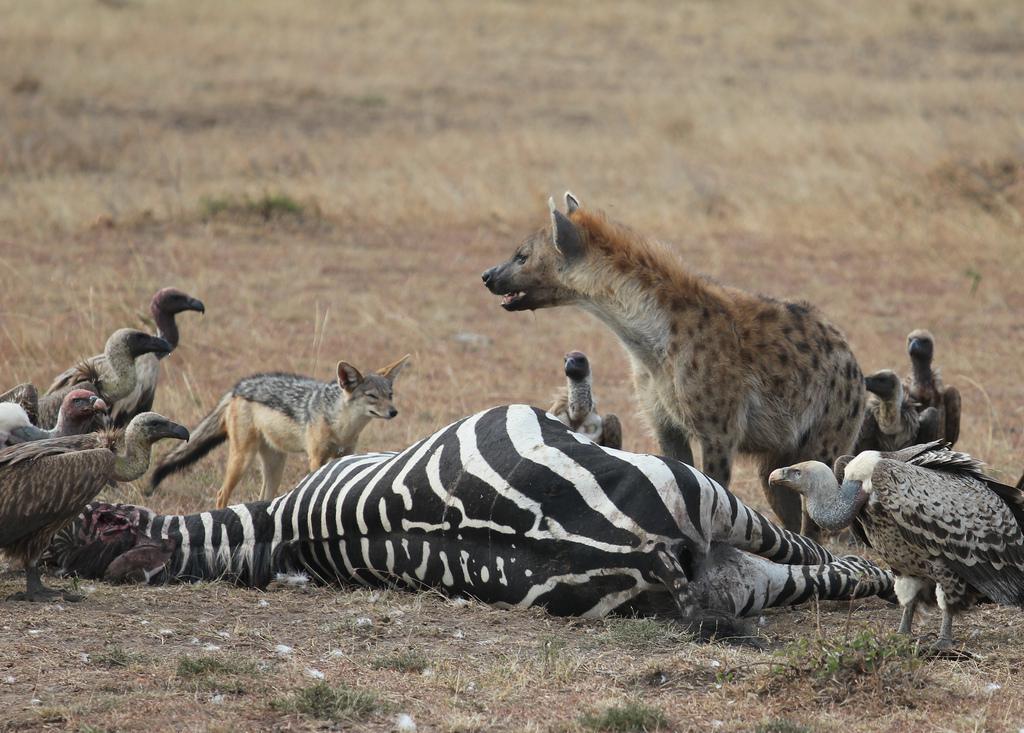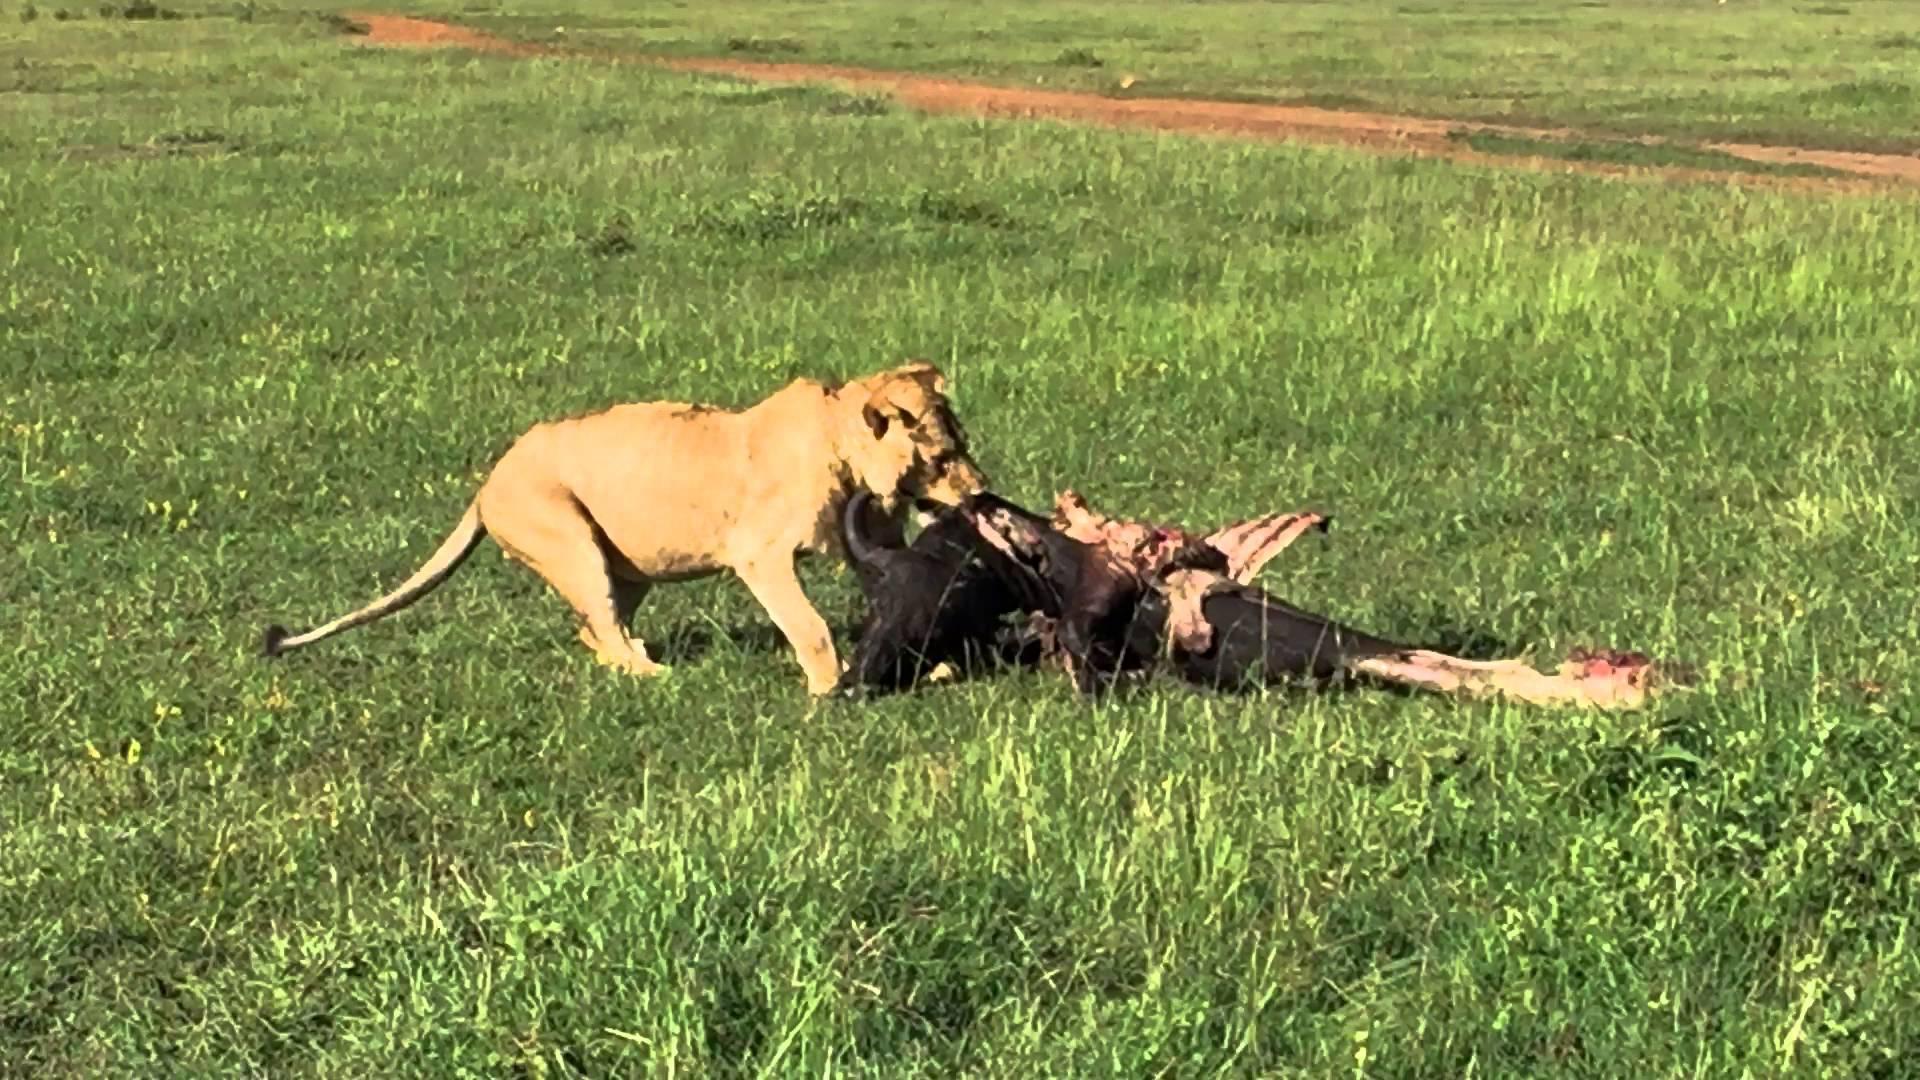The first image is the image on the left, the second image is the image on the right. Assess this claim about the two images: "One image contains a vulture whose face is visible". Correct or not? Answer yes or no. No. 